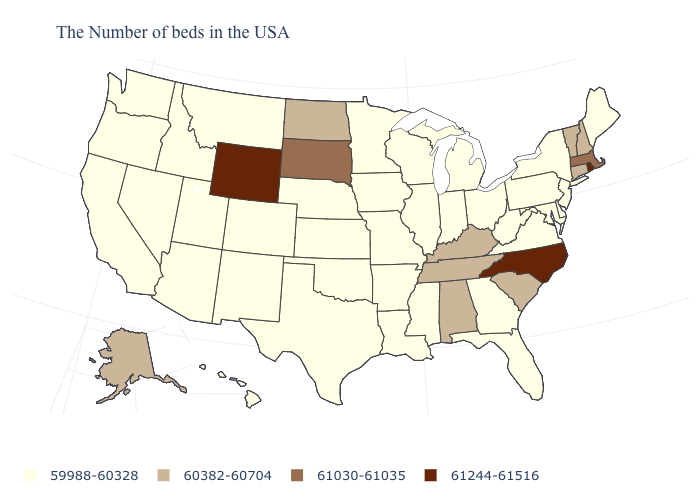What is the highest value in the USA?
Be succinct. 61244-61516. What is the value of Mississippi?
Short answer required. 59988-60328. Name the states that have a value in the range 59988-60328?
Be succinct. Maine, New York, New Jersey, Delaware, Maryland, Pennsylvania, Virginia, West Virginia, Ohio, Florida, Georgia, Michigan, Indiana, Wisconsin, Illinois, Mississippi, Louisiana, Missouri, Arkansas, Minnesota, Iowa, Kansas, Nebraska, Oklahoma, Texas, Colorado, New Mexico, Utah, Montana, Arizona, Idaho, Nevada, California, Washington, Oregon, Hawaii. Does the first symbol in the legend represent the smallest category?
Short answer required. Yes. What is the value of Florida?
Quick response, please. 59988-60328. What is the highest value in the USA?
Keep it brief. 61244-61516. Which states have the lowest value in the USA?
Quick response, please. Maine, New York, New Jersey, Delaware, Maryland, Pennsylvania, Virginia, West Virginia, Ohio, Florida, Georgia, Michigan, Indiana, Wisconsin, Illinois, Mississippi, Louisiana, Missouri, Arkansas, Minnesota, Iowa, Kansas, Nebraska, Oklahoma, Texas, Colorado, New Mexico, Utah, Montana, Arizona, Idaho, Nevada, California, Washington, Oregon, Hawaii. Name the states that have a value in the range 59988-60328?
Answer briefly. Maine, New York, New Jersey, Delaware, Maryland, Pennsylvania, Virginia, West Virginia, Ohio, Florida, Georgia, Michigan, Indiana, Wisconsin, Illinois, Mississippi, Louisiana, Missouri, Arkansas, Minnesota, Iowa, Kansas, Nebraska, Oklahoma, Texas, Colorado, New Mexico, Utah, Montana, Arizona, Idaho, Nevada, California, Washington, Oregon, Hawaii. Does South Dakota have a higher value than Colorado?
Be succinct. Yes. Name the states that have a value in the range 60382-60704?
Quick response, please. New Hampshire, Vermont, Connecticut, South Carolina, Kentucky, Alabama, Tennessee, North Dakota, Alaska. What is the highest value in the Northeast ?
Short answer required. 61244-61516. Among the states that border Minnesota , which have the highest value?
Concise answer only. South Dakota. What is the value of Michigan?
Answer briefly. 59988-60328. Among the states that border New Mexico , which have the lowest value?
Keep it brief. Oklahoma, Texas, Colorado, Utah, Arizona. What is the highest value in states that border New Hampshire?
Keep it brief. 61030-61035. 